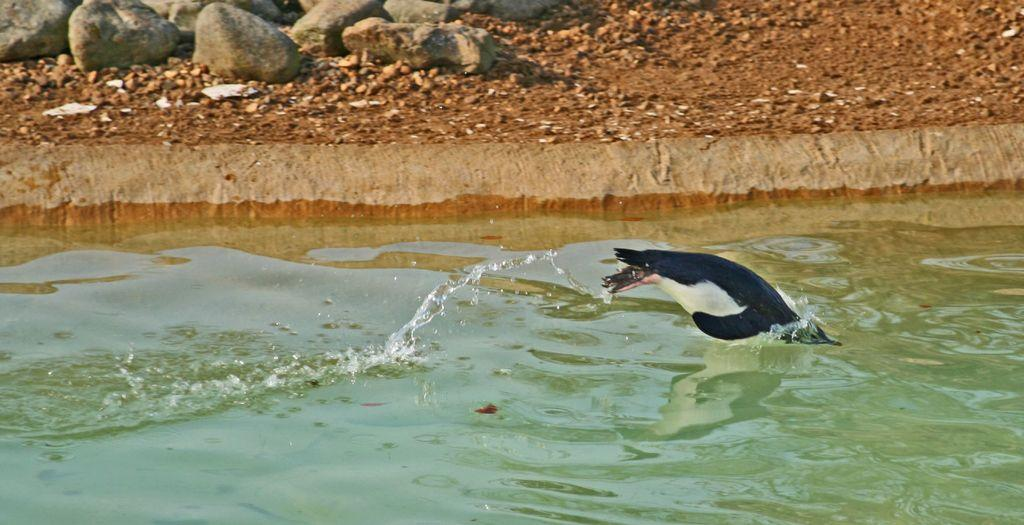What type of animal is present in the image? There is an animal in the image, but the specific type cannot be determined from the provided facts. What natural element is visible in the image? There is water visible in the image. What can be seen on the ground in the background of the image? There are stones on the ground in the background of the image. What day of the week is depicted in the image? The provided facts do not mention any specific day of the week, so it cannot be determined from the image. What type of machine is present in the image? There is no machine present in the image; it features an animal and water. 